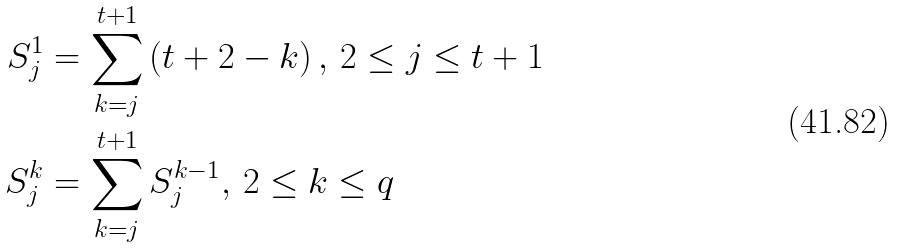Convert formula to latex. <formula><loc_0><loc_0><loc_500><loc_500>S _ { j } ^ { 1 } & = \sum _ { k = j } ^ { t + 1 } \left ( t + 2 - k \right ) , \, 2 \leq j \leq t + 1 \\ S _ { j } ^ { k } & = \sum _ { k = j } ^ { t + 1 } S _ { j } ^ { k - 1 } , \, 2 \leq k \leq q</formula> 